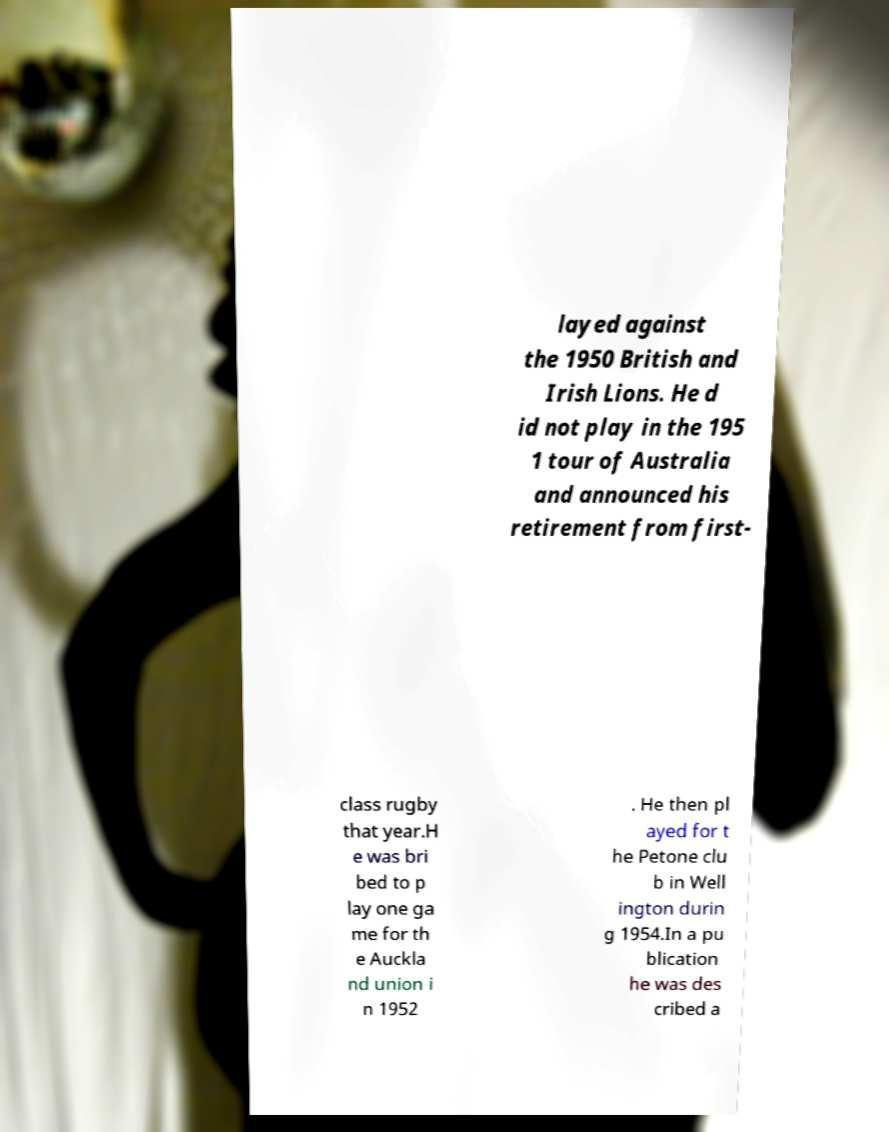Could you assist in decoding the text presented in this image and type it out clearly? layed against the 1950 British and Irish Lions. He d id not play in the 195 1 tour of Australia and announced his retirement from first- class rugby that year.H e was bri bed to p lay one ga me for th e Auckla nd union i n 1952 . He then pl ayed for t he Petone clu b in Well ington durin g 1954.In a pu blication he was des cribed a 